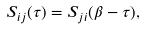<formula> <loc_0><loc_0><loc_500><loc_500>S _ { i j } ( \tau ) = S _ { j i } ( \beta - \tau ) ,</formula> 